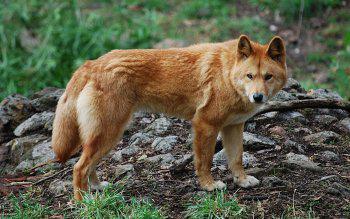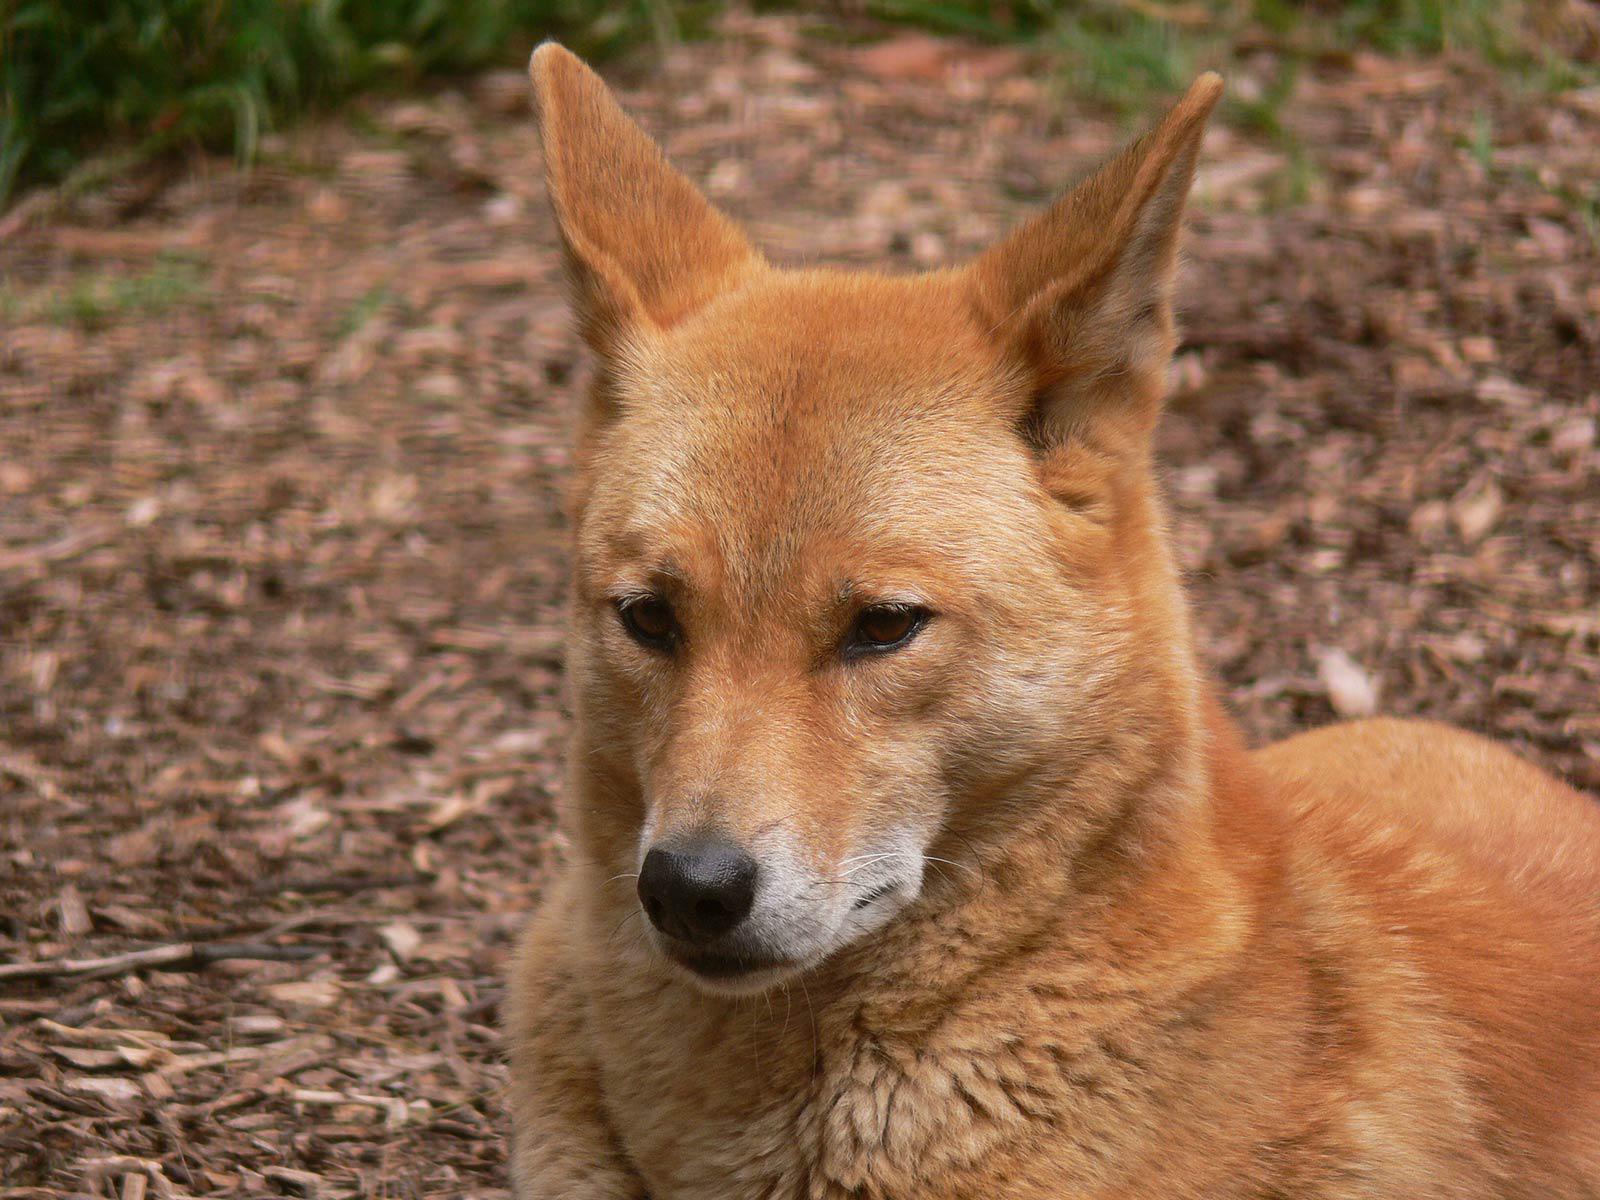The first image is the image on the left, the second image is the image on the right. Analyze the images presented: Is the assertion "There is an animal lying down in one of the images" valid? Answer yes or no. No. 